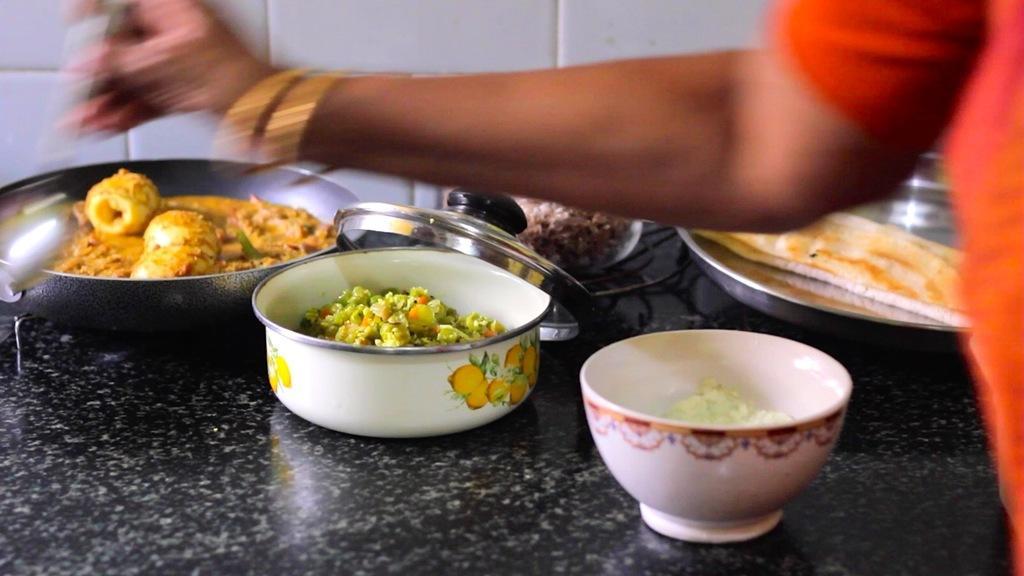Could you give a brief overview of what you see in this image? In this image there are food items on the table. In front of the table there is a person. 